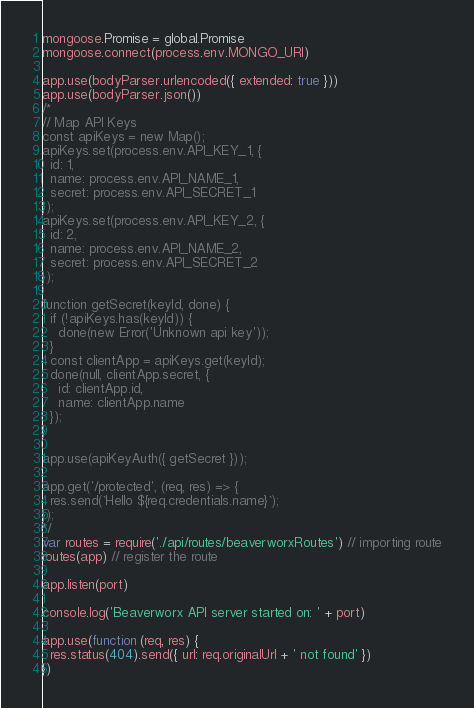Convert code to text. <code><loc_0><loc_0><loc_500><loc_500><_JavaScript_>mongoose.Promise = global.Promise
mongoose.connect(process.env.MONGO_URI)

app.use(bodyParser.urlencoded({ extended: true }))
app.use(bodyParser.json())
/*
// Map API Keys
const apiKeys = new Map();
apiKeys.set(process.env.API_KEY_1, {
  id: 1,
  name: process.env.API_NAME_1,
  secret: process.env.API_SECRET_1
});
apiKeys.set(process.env.API_KEY_2, {
  id: 2,
  name: process.env.API_NAME_2,
  secret: process.env.API_SECRET_2
});

function getSecret(keyId, done) {
  if (!apiKeys.has(keyId)) {
    done(new Error('Unknown api key'));
  }
  const clientApp = apiKeys.get(keyId);
  done(null, clientApp.secret, {
    id: clientApp.id,
    name: clientApp.name
  });
}

app.use(apiKeyAuth({ getSecret }));

app.get('/protected', (req, res) => {
  res.send(`Hello ${req.credentials.name}`);
});
*/
var routes = require('./api/routes/beaverworxRoutes') // importing route
routes(app) // register the route

app.listen(port)

console.log('Beaverworx API server started on: ' + port)

app.use(function (req, res) {
  res.status(404).send({ url: req.originalUrl + ' not found' })
})</code> 